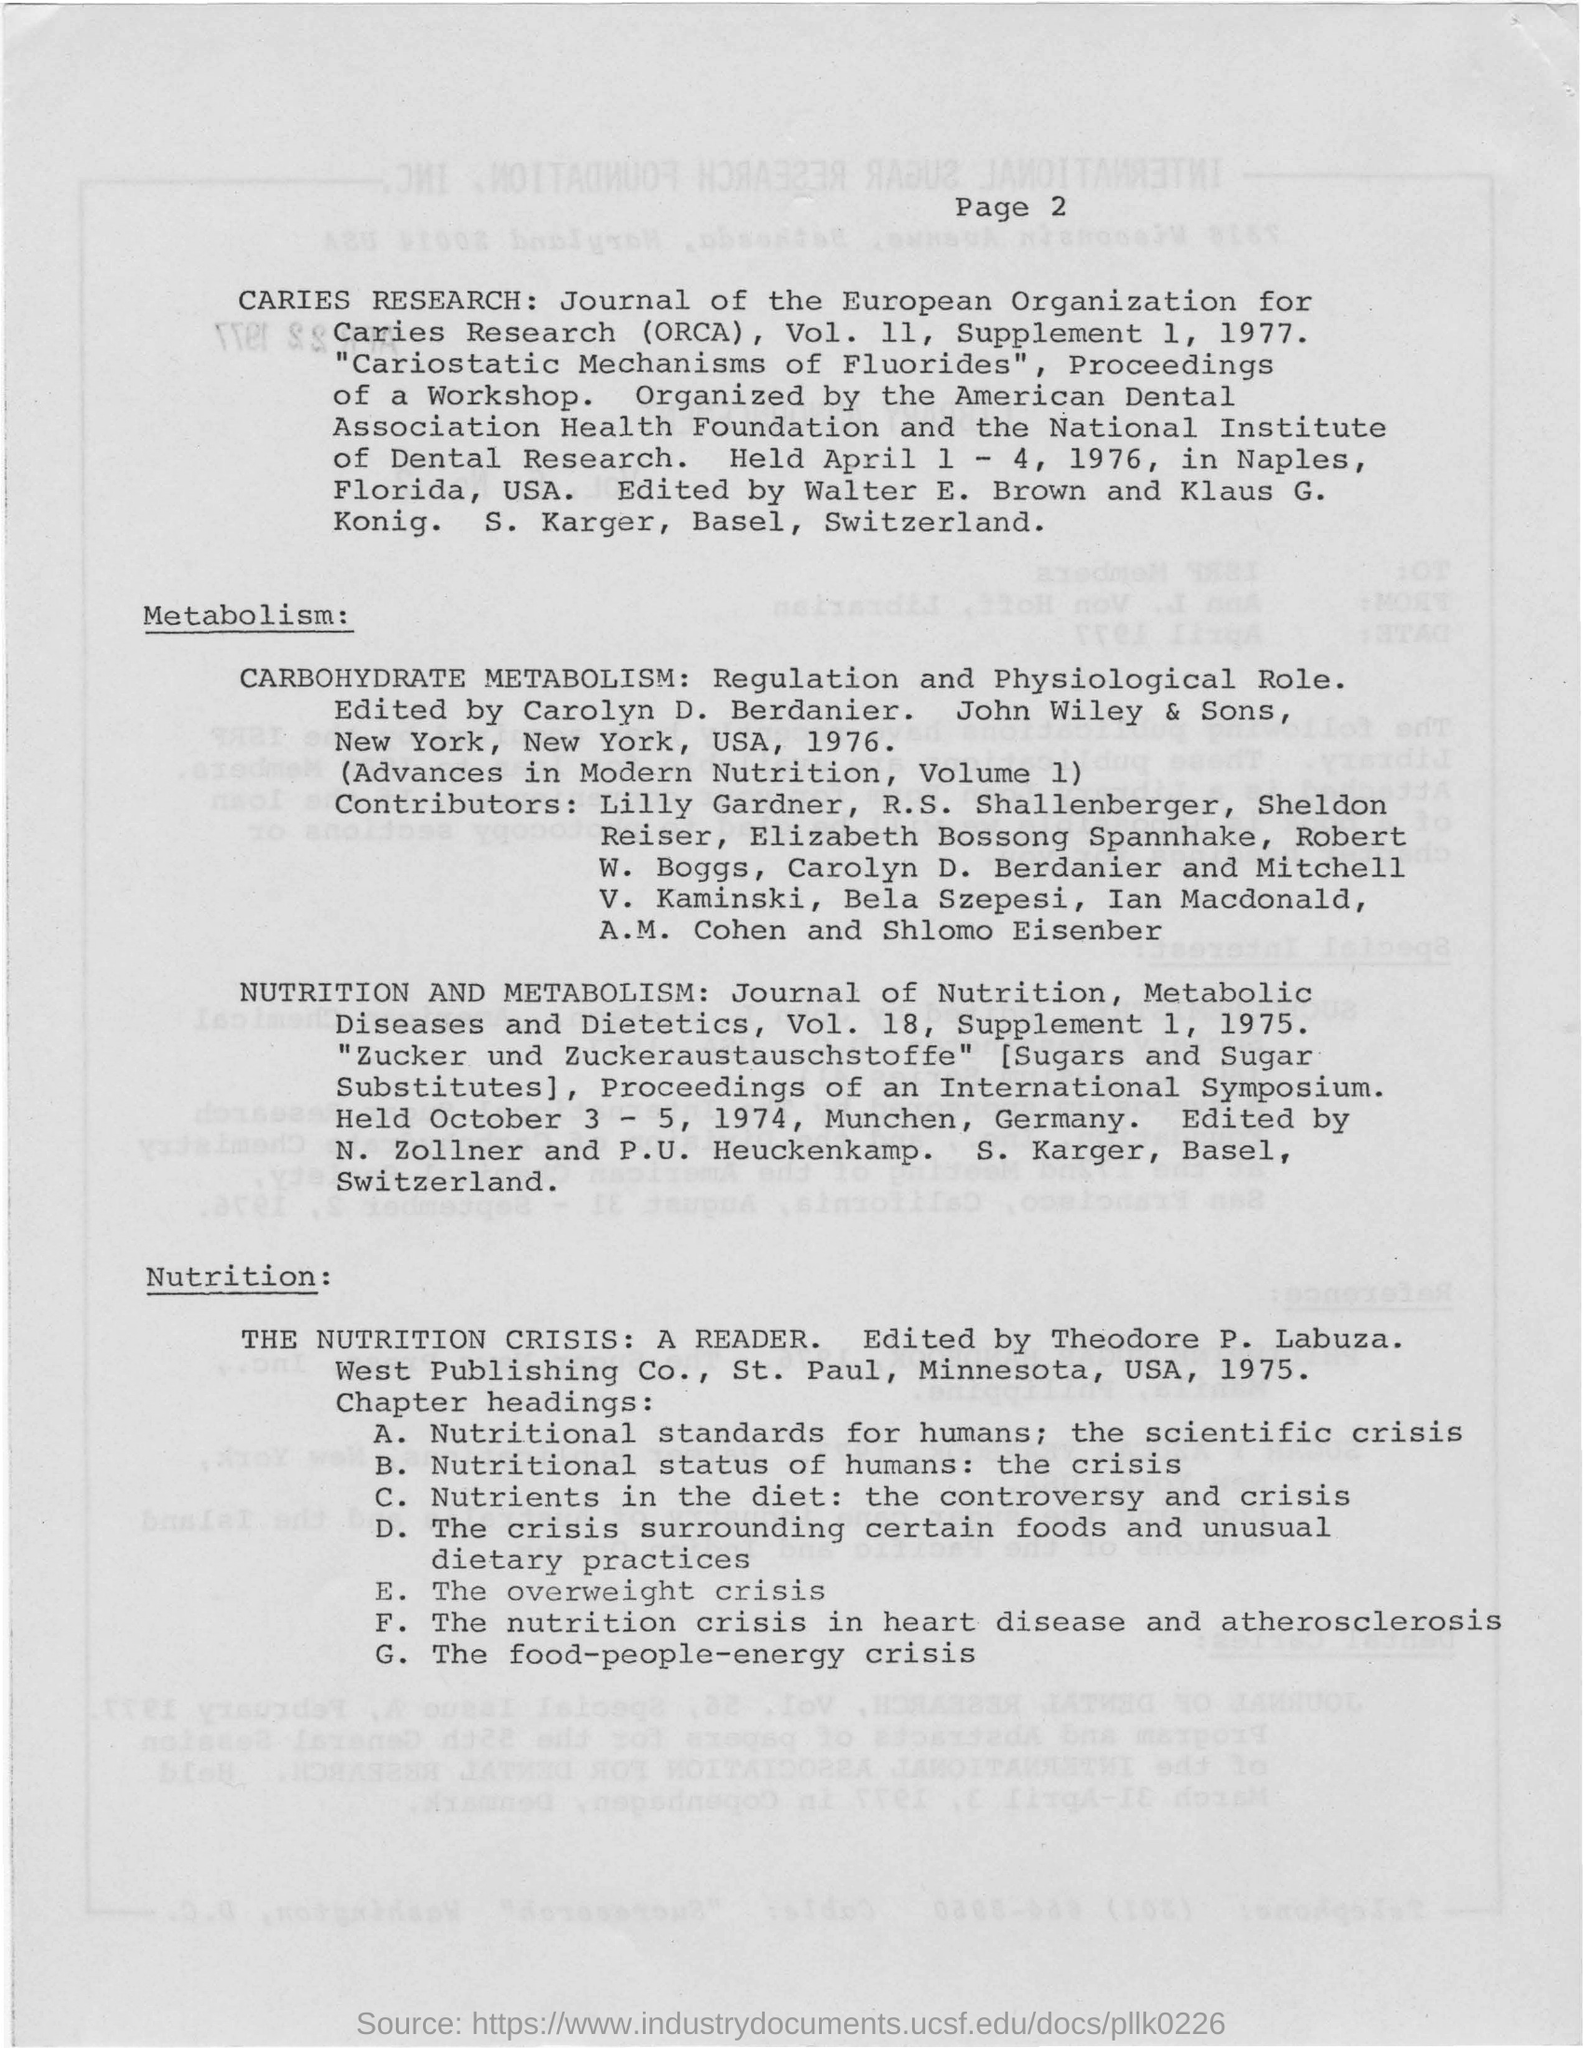Specify some key components in this picture. ORCA stands for "Organization for Caries Research and Prevention. 